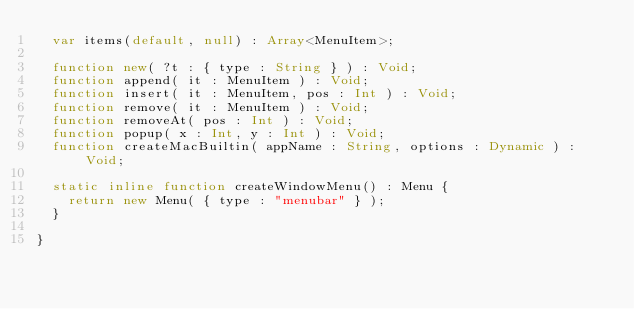<code> <loc_0><loc_0><loc_500><loc_500><_Haxe_>	var items(default, null) : Array<MenuItem>;

	function new( ?t : { type : String } ) : Void;
	function append( it : MenuItem ) : Void;
	function insert( it : MenuItem, pos : Int ) : Void;
	function remove( it : MenuItem ) : Void;
	function removeAt( pos : Int ) : Void;
	function popup( x : Int, y : Int ) : Void;
	function createMacBuiltin( appName : String, options : Dynamic ) : Void;

	static inline function createWindowMenu() : Menu {
		return new Menu( { type : "menubar" } );
	}

}</code> 